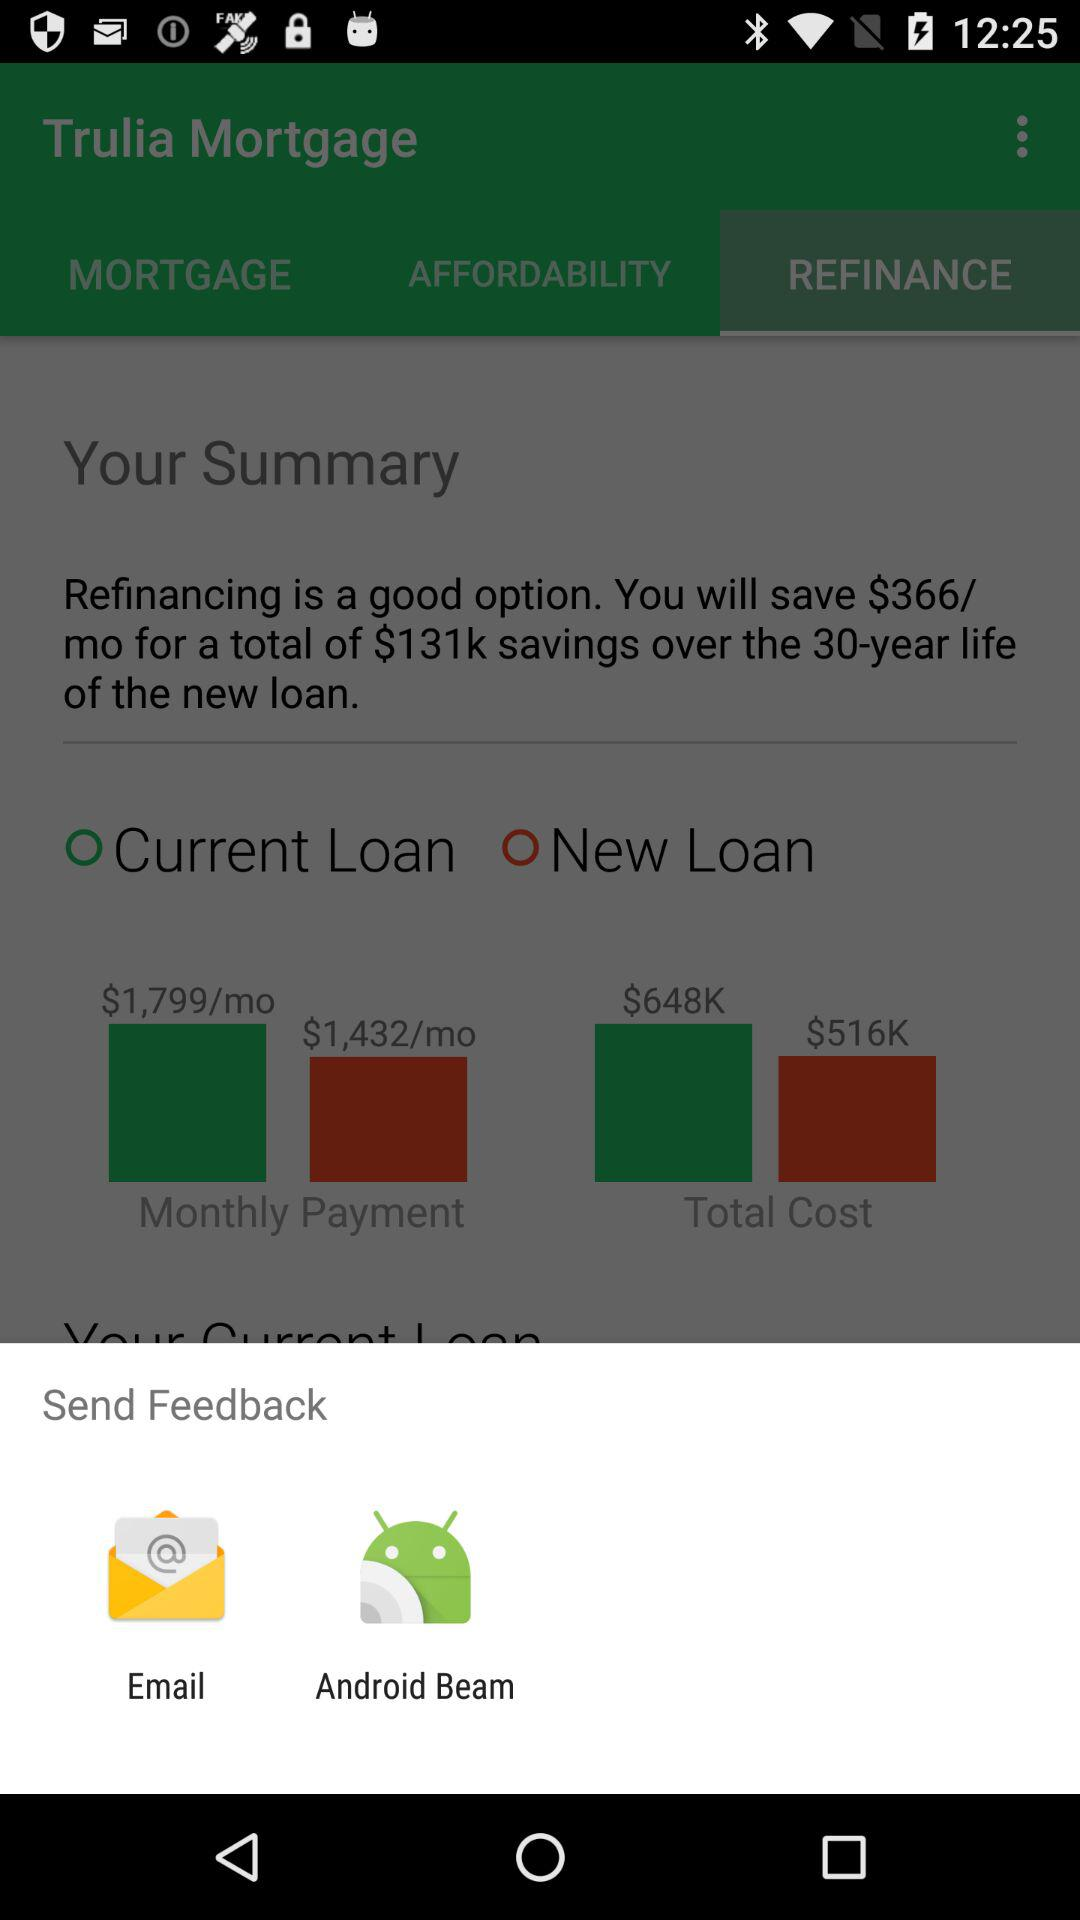What are the different applications through which we can send feedback? The different applications through which you can send feedback are "Email" and "Android Beam". 